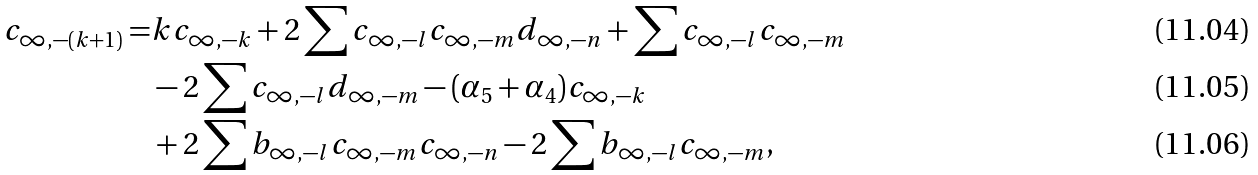<formula> <loc_0><loc_0><loc_500><loc_500>c _ { \infty , - ( k + 1 ) } = & k c _ { \infty , - k } + 2 \sum c _ { \infty , - l } c _ { \infty , - m } d _ { \infty , - n } + \sum c _ { \infty , - l } c _ { \infty , - m } \\ & - 2 \sum c _ { \infty , - l } d _ { \infty , - m } - ( \alpha _ { 5 } + \alpha _ { 4 } ) c _ { \infty , - k } \\ & + 2 \sum b _ { \infty , - l } c _ { \infty , - m } c _ { \infty , - n } - 2 \sum b _ { \infty , - l } c _ { \infty , - m } ,</formula> 